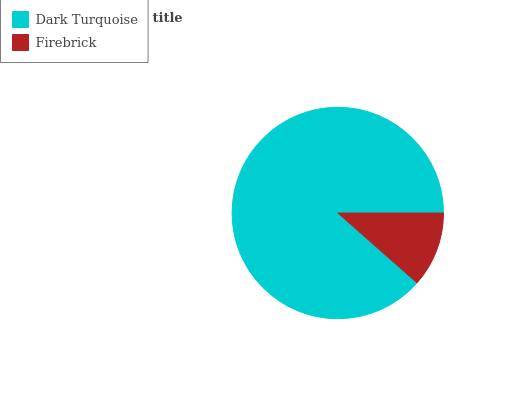Is Firebrick the minimum?
Answer yes or no. Yes. Is Dark Turquoise the maximum?
Answer yes or no. Yes. Is Firebrick the maximum?
Answer yes or no. No. Is Dark Turquoise greater than Firebrick?
Answer yes or no. Yes. Is Firebrick less than Dark Turquoise?
Answer yes or no. Yes. Is Firebrick greater than Dark Turquoise?
Answer yes or no. No. Is Dark Turquoise less than Firebrick?
Answer yes or no. No. Is Dark Turquoise the high median?
Answer yes or no. Yes. Is Firebrick the low median?
Answer yes or no. Yes. Is Firebrick the high median?
Answer yes or no. No. Is Dark Turquoise the low median?
Answer yes or no. No. 